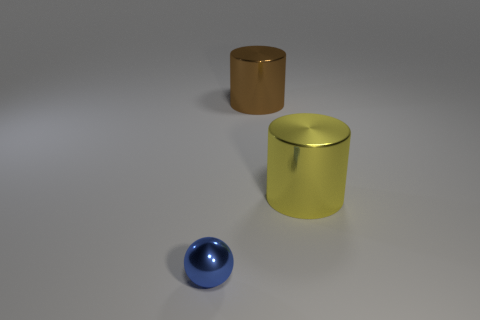Subtract 1 blue balls. How many objects are left? 2 Subtract all balls. How many objects are left? 2 Subtract 1 spheres. How many spheres are left? 0 Subtract all green cylinders. Subtract all brown cubes. How many cylinders are left? 2 Subtract all yellow balls. How many purple cylinders are left? 0 Subtract all metallic cylinders. Subtract all big spheres. How many objects are left? 1 Add 2 large brown cylinders. How many large brown cylinders are left? 3 Add 1 big blue matte cubes. How many big blue matte cubes exist? 1 Add 2 red shiny cylinders. How many objects exist? 5 